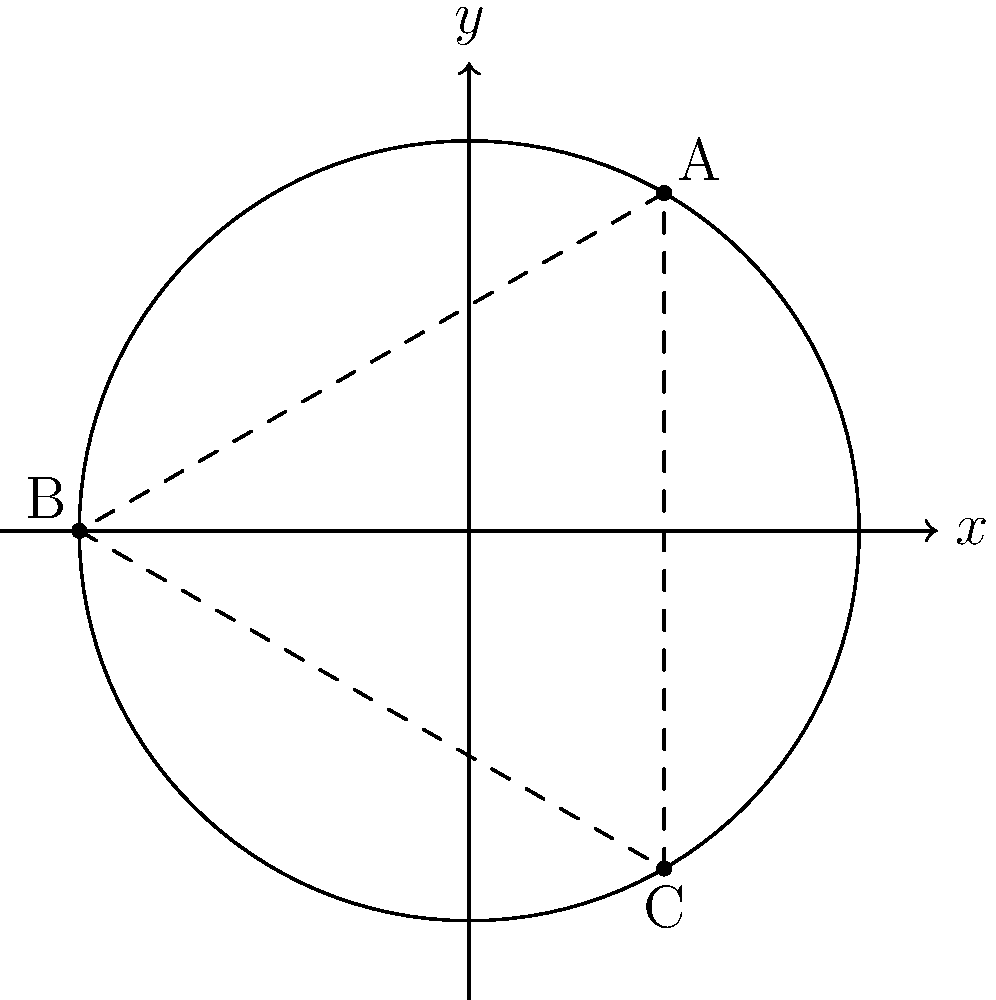As a naval strategist, you are tasked with determining the optimal patrol route for three vessels in a circular defense perimeter. The vessels are stationed at points A, B, and C, equally spaced around the circle. If the radius of the perimeter is 10 nautical miles and the first vessel starts at coordinates $(5\sqrt{3}, 5)$, what is the total distance the vessels must travel to complete one full rotation of their triangular patrol route? To solve this problem, we'll follow these steps:

1) First, we need to identify the coordinates of all three points:
   A: $(5\sqrt{3}, 5)$
   B: $(-5\sqrt{3}, 5)$ (120° or $2\pi/3$ radians from A)
   C: $(0, -10)$ (240° or $4\pi/3$ radians from A)

2) The patrol route forms an equilateral triangle inscribed in the circle. To find the side length of this triangle, we can use the distance formula between two points:

   $d = \sqrt{(x_2-x_1)^2 + (y_2-y_1)^2}$

3) Let's calculate the distance between A and B:

   $d_{AB} = \sqrt{((-5\sqrt{3})-(5\sqrt{3}))^2 + (5-5)^2}$
   $= \sqrt{(-10\sqrt{3})^2 + 0^2}$
   $= \sqrt{300}$
   $= 10\sqrt{3}$

4) Since the triangle is equilateral, all sides are equal. The total distance traveled is the sum of all three sides:

   Total distance = $3 * 10\sqrt{3} = 30\sqrt{3}$ nautical miles

Therefore, the vessels must travel a total of $30\sqrt{3}$ nautical miles to complete one full rotation of their triangular patrol route.
Answer: $30\sqrt{3}$ nautical miles 